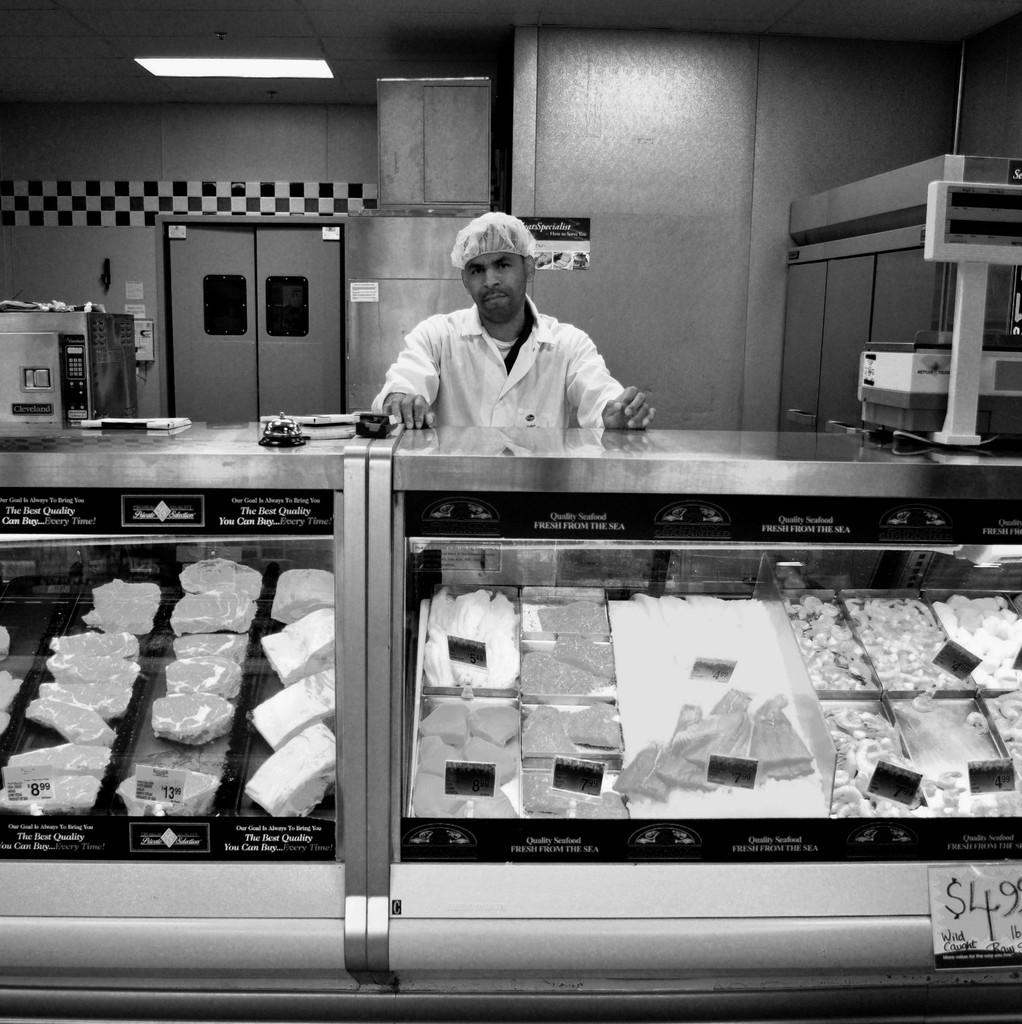<image>
Share a concise interpretation of the image provided. A deli counter with brands og meat that claim to be "The Best Quality You Can Buy". 